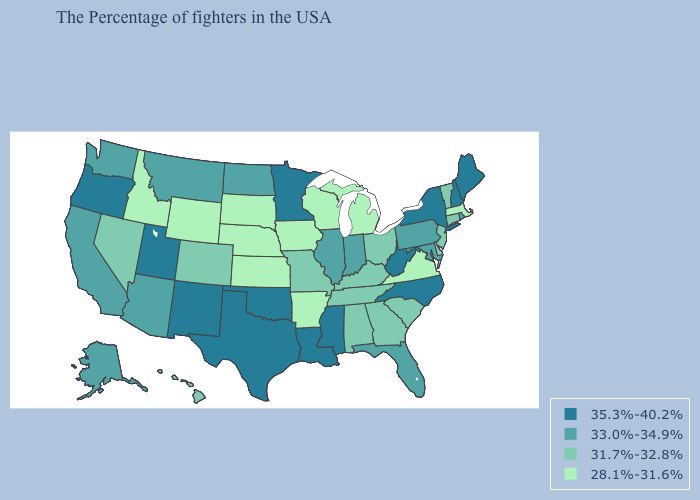Is the legend a continuous bar?
Concise answer only. No. Among the states that border Utah , does Wyoming have the lowest value?
Give a very brief answer. Yes. Name the states that have a value in the range 28.1%-31.6%?
Keep it brief. Massachusetts, Virginia, Michigan, Wisconsin, Arkansas, Iowa, Kansas, Nebraska, South Dakota, Wyoming, Idaho. Does Alaska have the lowest value in the West?
Give a very brief answer. No. Name the states that have a value in the range 28.1%-31.6%?
Quick response, please. Massachusetts, Virginia, Michigan, Wisconsin, Arkansas, Iowa, Kansas, Nebraska, South Dakota, Wyoming, Idaho. Which states have the lowest value in the USA?
Write a very short answer. Massachusetts, Virginia, Michigan, Wisconsin, Arkansas, Iowa, Kansas, Nebraska, South Dakota, Wyoming, Idaho. What is the lowest value in the MidWest?
Keep it brief. 28.1%-31.6%. Does New Jersey have a lower value than Missouri?
Write a very short answer. No. Does Alabama have the highest value in the USA?
Give a very brief answer. No. Name the states that have a value in the range 35.3%-40.2%?
Write a very short answer. Maine, New Hampshire, New York, North Carolina, West Virginia, Mississippi, Louisiana, Minnesota, Oklahoma, Texas, New Mexico, Utah, Oregon. What is the value of Idaho?
Answer briefly. 28.1%-31.6%. What is the lowest value in the South?
Quick response, please. 28.1%-31.6%. Name the states that have a value in the range 33.0%-34.9%?
Keep it brief. Rhode Island, Maryland, Pennsylvania, Florida, Indiana, Illinois, North Dakota, Montana, Arizona, California, Washington, Alaska. Among the states that border South Carolina , which have the lowest value?
Quick response, please. Georgia. Which states hav the highest value in the South?
Be succinct. North Carolina, West Virginia, Mississippi, Louisiana, Oklahoma, Texas. 